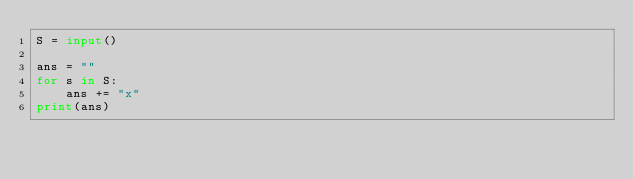<code> <loc_0><loc_0><loc_500><loc_500><_Python_>S = input()

ans = ""
for s in S:
    ans += "x"
print(ans)</code> 